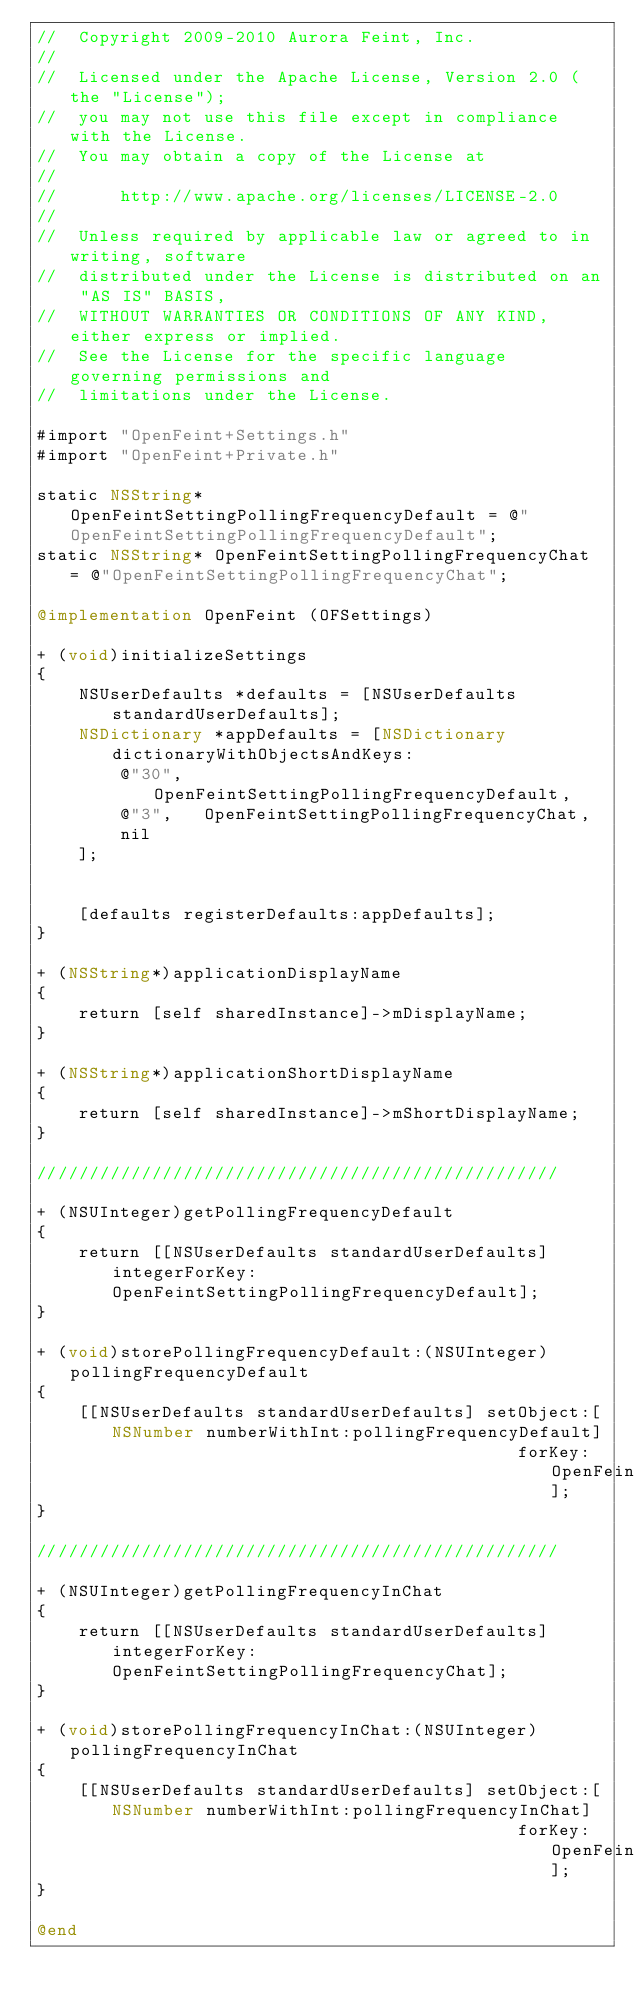<code> <loc_0><loc_0><loc_500><loc_500><_ObjectiveC_>//  Copyright 2009-2010 Aurora Feint, Inc.
// 
//  Licensed under the Apache License, Version 2.0 (the "License");
//  you may not use this file except in compliance with the License.
//  You may obtain a copy of the License at
//  
//  	http://www.apache.org/licenses/LICENSE-2.0
//  	
//  Unless required by applicable law or agreed to in writing, software
//  distributed under the License is distributed on an "AS IS" BASIS,
//  WITHOUT WARRANTIES OR CONDITIONS OF ANY KIND, either express or implied.
//  See the License for the specific language governing permissions and
//  limitations under the License.

#import "OpenFeint+Settings.h"
#import "OpenFeint+Private.h"

static NSString* OpenFeintSettingPollingFrequencyDefault = @"OpenFeintSettingPollingFrequencyDefault";
static NSString* OpenFeintSettingPollingFrequencyChat = @"OpenFeintSettingPollingFrequencyChat";

@implementation OpenFeint (OFSettings)

+ (void)initializeSettings
{
	NSUserDefaults *defaults = [NSUserDefaults standardUserDefaults];
	NSDictionary *appDefaults = [NSDictionary dictionaryWithObjectsAndKeys:
		@"30",  OpenFeintSettingPollingFrequencyDefault,
		@"3",   OpenFeintSettingPollingFrequencyChat,
		nil
	];
	
	
	[defaults registerDefaults:appDefaults];
}

+ (NSString*)applicationDisplayName
{
	return [self sharedInstance]->mDisplayName;
}	 		

+ (NSString*)applicationShortDisplayName
{
	return [self sharedInstance]->mShortDisplayName;
}

//////////////////////////////////////////////////

+ (NSUInteger)getPollingFrequencyDefault
{
	return [[NSUserDefaults standardUserDefaults] integerForKey:OpenFeintSettingPollingFrequencyDefault];
}

+ (void)storePollingFrequencyDefault:(NSUInteger)pollingFrequencyDefault
{
	[[NSUserDefaults standardUserDefaults] setObject:[NSNumber numberWithInt:pollingFrequencyDefault]
											  forKey:OpenFeintSettingPollingFrequencyDefault];
}

//////////////////////////////////////////////////

+ (NSUInteger)getPollingFrequencyInChat
{
	return [[NSUserDefaults standardUserDefaults] integerForKey:OpenFeintSettingPollingFrequencyChat];
}

+ (void)storePollingFrequencyInChat:(NSUInteger)pollingFrequencyInChat
{
	[[NSUserDefaults standardUserDefaults] setObject:[NSNumber numberWithInt:pollingFrequencyInChat]
											  forKey:OpenFeintSettingPollingFrequencyChat];
}

@end
</code> 